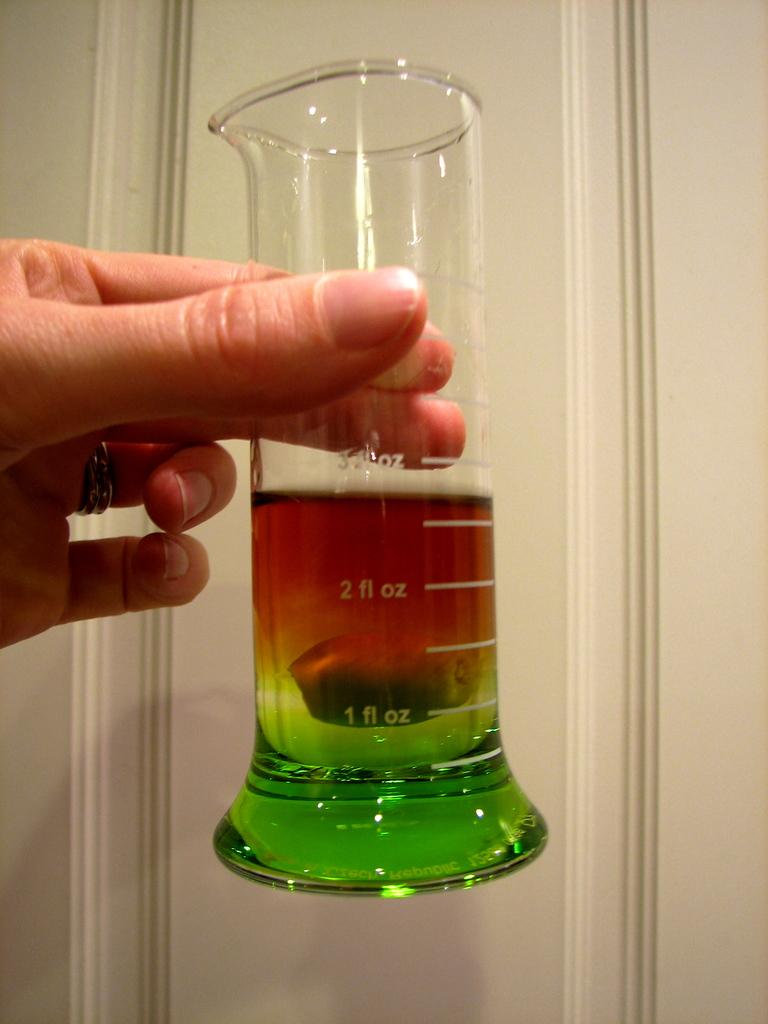<image>
Create a compact narrative representing the image presented. Person holding a beaker with the liquid almost at 3 fl oz. 